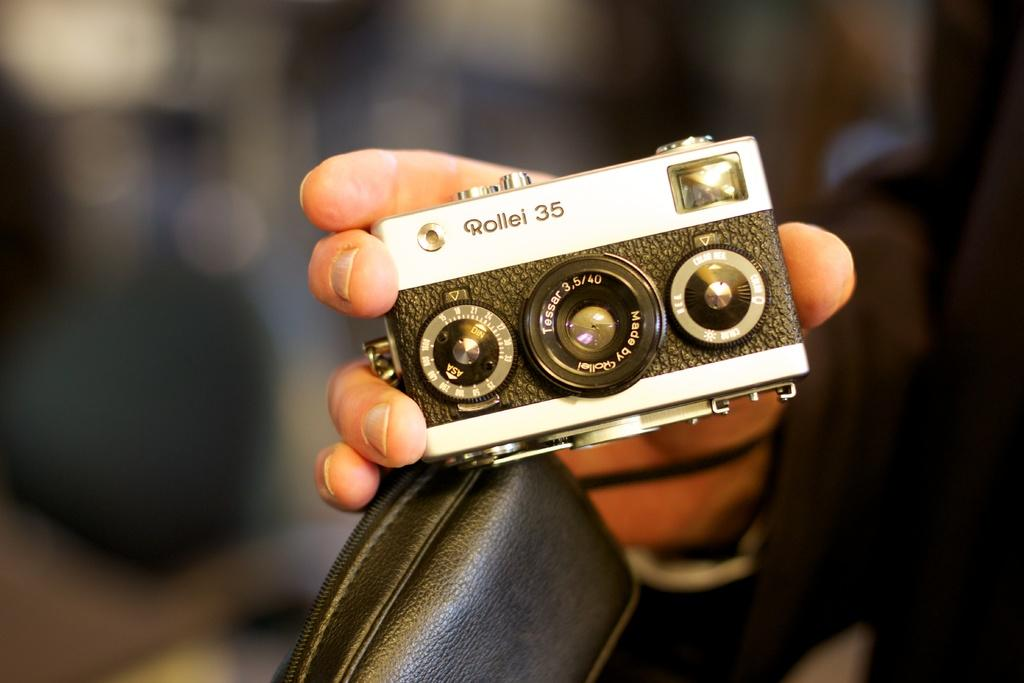<image>
Give a short and clear explanation of the subsequent image. a person holding a Rollei 35mm camera with a laser 3.5/4 lens 